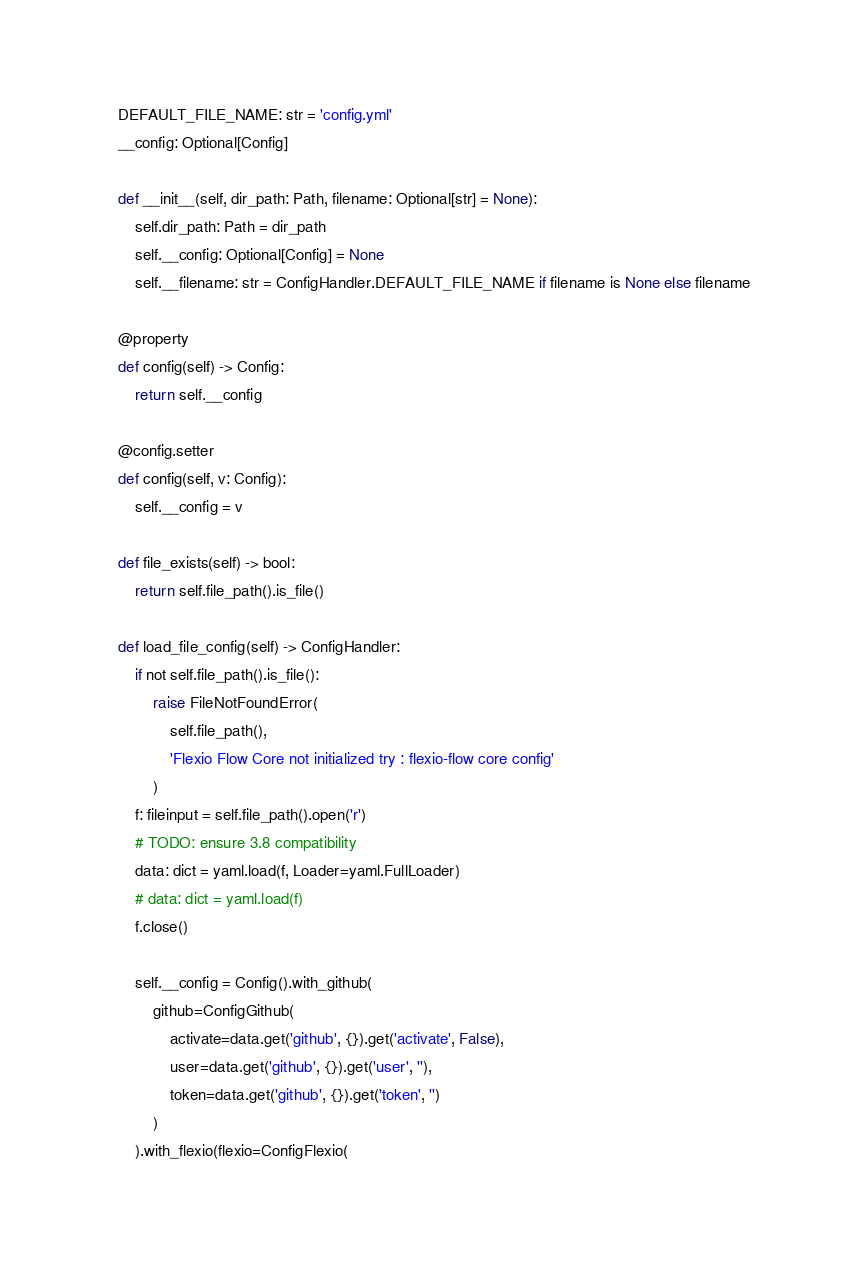<code> <loc_0><loc_0><loc_500><loc_500><_Python_>    DEFAULT_FILE_NAME: str = 'config.yml'
    __config: Optional[Config]

    def __init__(self, dir_path: Path, filename: Optional[str] = None):
        self.dir_path: Path = dir_path
        self.__config: Optional[Config] = None
        self.__filename: str = ConfigHandler.DEFAULT_FILE_NAME if filename is None else filename

    @property
    def config(self) -> Config:
        return self.__config

    @config.setter
    def config(self, v: Config):
        self.__config = v

    def file_exists(self) -> bool:
        return self.file_path().is_file()

    def load_file_config(self) -> ConfigHandler:
        if not self.file_path().is_file():
            raise FileNotFoundError(
                self.file_path(),
                'Flexio Flow Core not initialized try : flexio-flow core config'
            )
        f: fileinput = self.file_path().open('r')
        # TODO: ensure 3.8 compatibility
        data: dict = yaml.load(f, Loader=yaml.FullLoader)
        # data: dict = yaml.load(f)
        f.close()

        self.__config = Config().with_github(
            github=ConfigGithub(
                activate=data.get('github', {}).get('activate', False),
                user=data.get('github', {}).get('user', ''),
                token=data.get('github', {}).get('token', '')
            )
        ).with_flexio(flexio=ConfigFlexio(</code> 